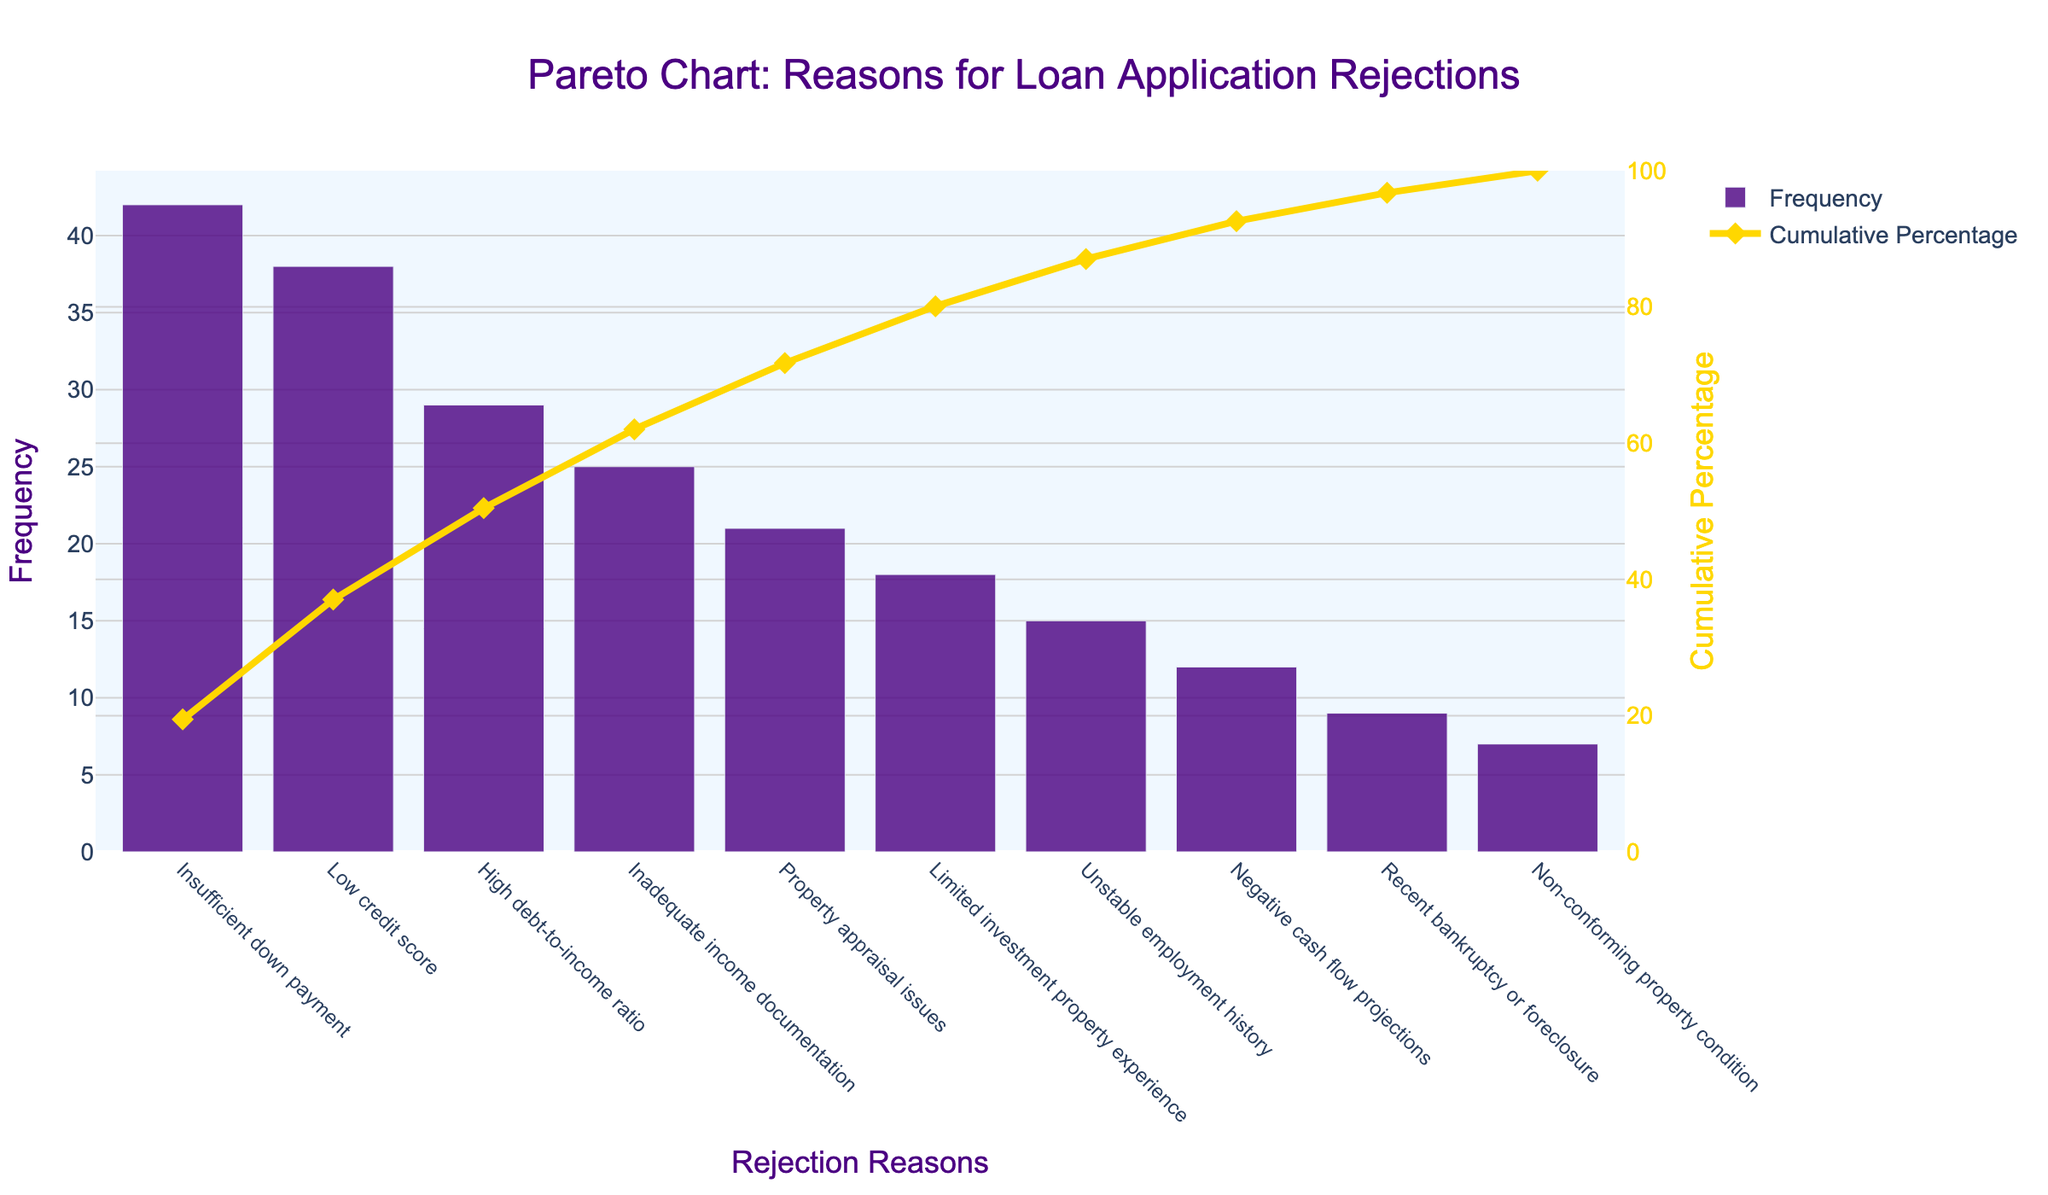What is the most common reason for loan application rejections shown in the Pareto chart? The bar chart shows that 'Insufficient down payment' has the highest frequency among the reasons listed.
Answer: Insufficient down payment What's the cumulative percentage of rejections accounted for by the top three reasons? The cumulative percentage for 'Insufficient down payment', 'Low credit score', and 'High debt-to-income ratio' can be found by summing the cumulative percentages for each reason up to the third rank: 28.8% (Insufficient down payment) + 55.8% (Low credit score) + 75.7% (High debt-to-income ratio).
Answer: 75.7% Which reason ranks fifth in terms of frequency, and what is its frequency? The fifth bar from the left represents ‘Property appraisal issues’, and its height indicates the frequency of 21.
Answer: Property appraisal issues with a frequency of 21 What's the difference in frequency between 'Insufficient down payment' and 'Low credit score'? 'Insufficient down payment' has a frequency of 42, and 'Low credit score' has a frequency of 38. The difference is 42 - 38.
Answer: 4 How does the frequency of 'Negative cash flow projections' compare to 'Recent bankruptcy or foreclosure'? 'Negative cash flow projections' has a frequency of 12, while 'Recent bankruptcy or foreclosure' has a frequency of 9. 12 is greater than 9.
Answer: Negative cash flow projections is greater than Recent bankruptcy or foreclosure At what cumulative percentage does the 'Non-conforming property condition' contribute to the total rejections? The cumulative percentage for 'Non-conforming property condition' can be found in the chart, where it shows approximately 100% at the endpoint.
Answer: 100% How many reasons have frequencies greater than 20? By counting the bars that have frequencies greater than 20, we see that there are three reasons: 'Insufficient down payment', 'Low credit score', and 'High debt-to-income ratio'.
Answer: 3 What percentage of rejections is accounted for by 'Limited investment property experience' and 'Unstable employment history' combined? 'Limited investment property experience' has a frequency of 18 and 'Unstable employment history' has 15. The cumulative percentage for 'Limited investment property experience' plus the additional frequency percentage for 'Unstable employment history' sums as follows: (18/216) * 100 + (15/216) * 100 ≈ 8.3% + 6.9% = 15.2%
Answer: 15.2% What is the frequency and cumulative percentage of 'Inadequate income documentation'? The bar corresponding to 'Inadequate income documentation' shows a frequency of 25 and the cumulative line indicates around 67%.
Answer: Frequency: 25, Cumulative Percentage: 67% If 'Insufficient down payment' issues are resolved, what would be the new cumulative percentage for 'Low credit score'? Without 'Insufficient down payment' (frequency 42), the new total frequency is 216 - 42 = 174. The new cumulative percentage for 'Low credit score' would be (38/174) * 100 ≈ 21.8%.
Answer: 21.8% 